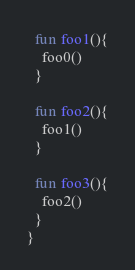<code> <loc_0><loc_0><loc_500><loc_500><_Kotlin_>
  fun foo1(){
    foo0()
  }

  fun foo2(){
    foo1()
  }

  fun foo3(){
    foo2()
  }
}</code> 